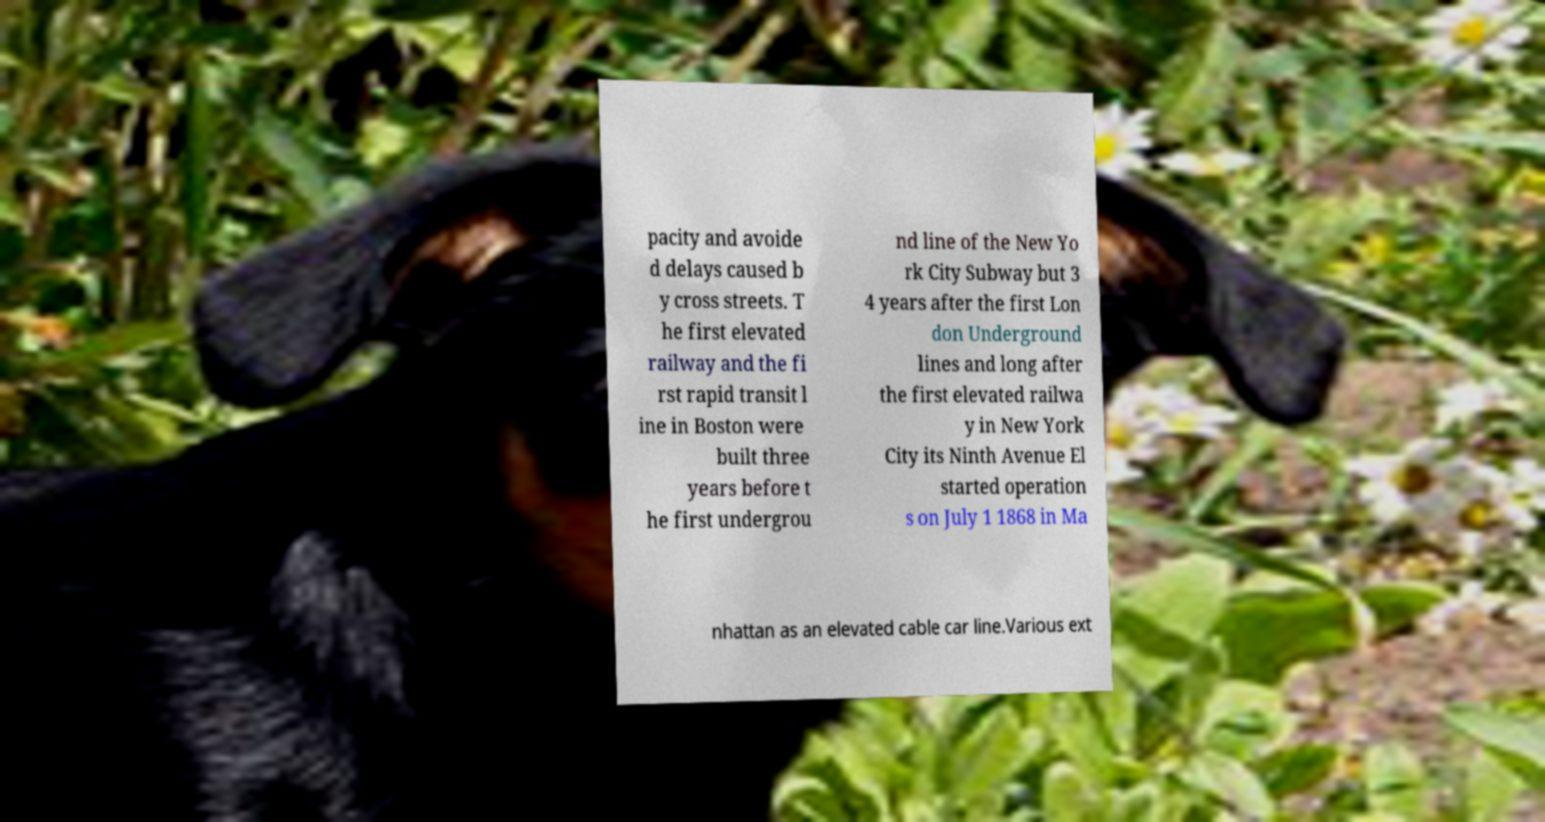What messages or text are displayed in this image? I need them in a readable, typed format. pacity and avoide d delays caused b y cross streets. T he first elevated railway and the fi rst rapid transit l ine in Boston were built three years before t he first undergrou nd line of the New Yo rk City Subway but 3 4 years after the first Lon don Underground lines and long after the first elevated railwa y in New York City its Ninth Avenue El started operation s on July 1 1868 in Ma nhattan as an elevated cable car line.Various ext 